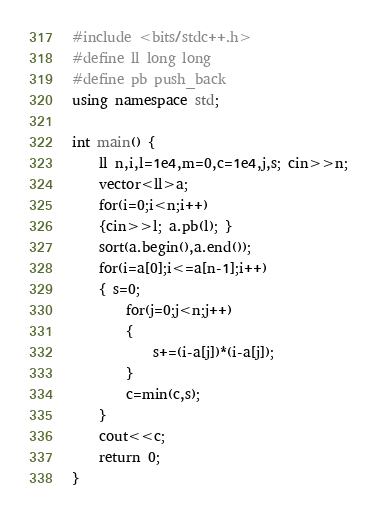<code> <loc_0><loc_0><loc_500><loc_500><_C++_>#include <bits/stdc++.h>
#define ll long long
#define pb push_back
using namespace std;

int main() {
    ll n,i,l=1e4,m=0,c=1e4,j,s; cin>>n; 
    vector<ll>a; 
    for(i=0;i<n;i++) 
    {cin>>l; a.pb(l); }
    sort(a.begin(),a.end());
    for(i=a[0];i<=a[n-1];i++)
    { s=0;
        for(j=0;j<n;j++)
        {
            s+=(i-a[j])*(i-a[j]);
        }
        c=min(c,s);
    }
    cout<<c;
	return 0;
}</code> 